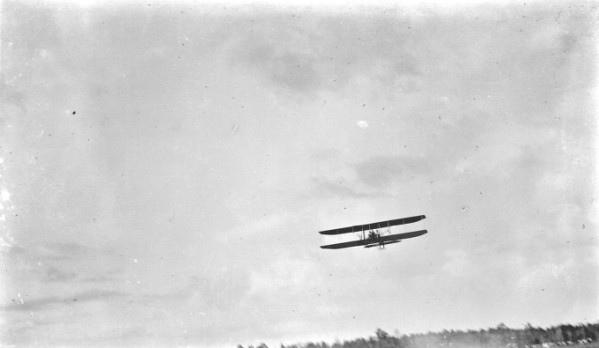Is this an antique airplane?
Concise answer only. Yes. What vehicle of transportation is in this photo?
Give a very brief answer. Airplane. Is there something flying in the sky?
Be succinct. Yes. 